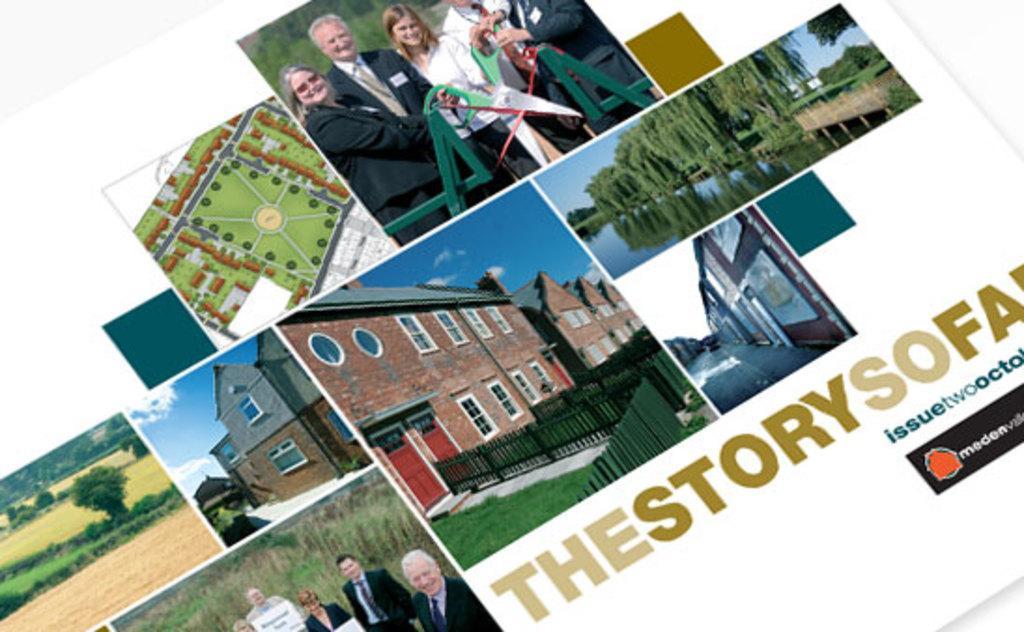In one or two sentences, can you explain what this image depicts? In this image I can see there is a collage of images and there are images of trees, people and there is an aerial view of fields. There is something written on it. 